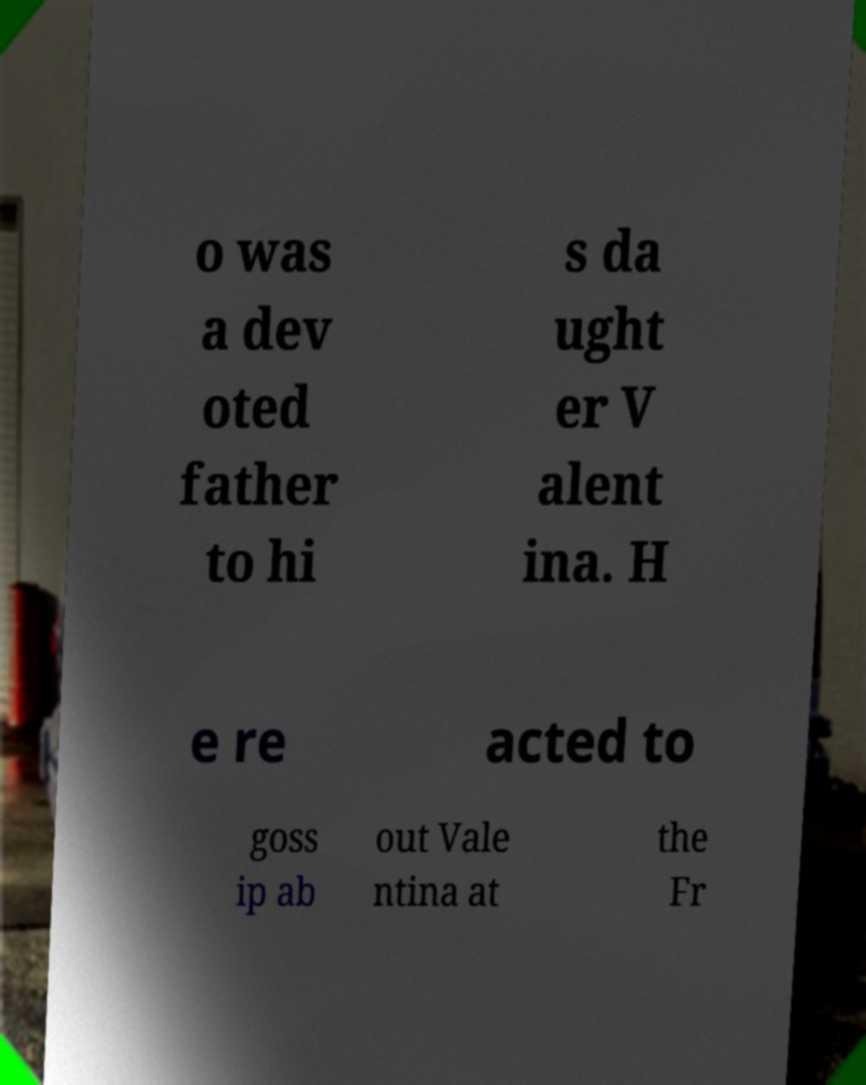Could you extract and type out the text from this image? o was a dev oted father to hi s da ught er V alent ina. H e re acted to goss ip ab out Vale ntina at the Fr 